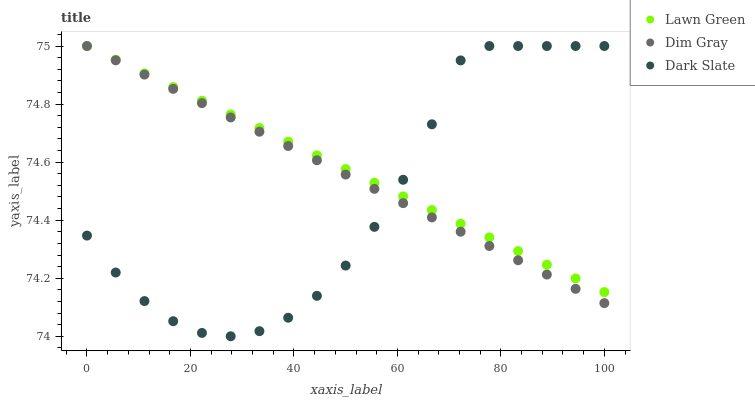Does Dark Slate have the minimum area under the curve?
Answer yes or no. Yes. Does Lawn Green have the maximum area under the curve?
Answer yes or no. Yes. Does Dim Gray have the minimum area under the curve?
Answer yes or no. No. Does Dim Gray have the maximum area under the curve?
Answer yes or no. No. Is Dim Gray the smoothest?
Answer yes or no. Yes. Is Dark Slate the roughest?
Answer yes or no. Yes. Is Dark Slate the smoothest?
Answer yes or no. No. Is Dim Gray the roughest?
Answer yes or no. No. Does Dark Slate have the lowest value?
Answer yes or no. Yes. Does Dim Gray have the lowest value?
Answer yes or no. No. Does Dark Slate have the highest value?
Answer yes or no. Yes. Does Lawn Green intersect Dark Slate?
Answer yes or no. Yes. Is Lawn Green less than Dark Slate?
Answer yes or no. No. Is Lawn Green greater than Dark Slate?
Answer yes or no. No. 